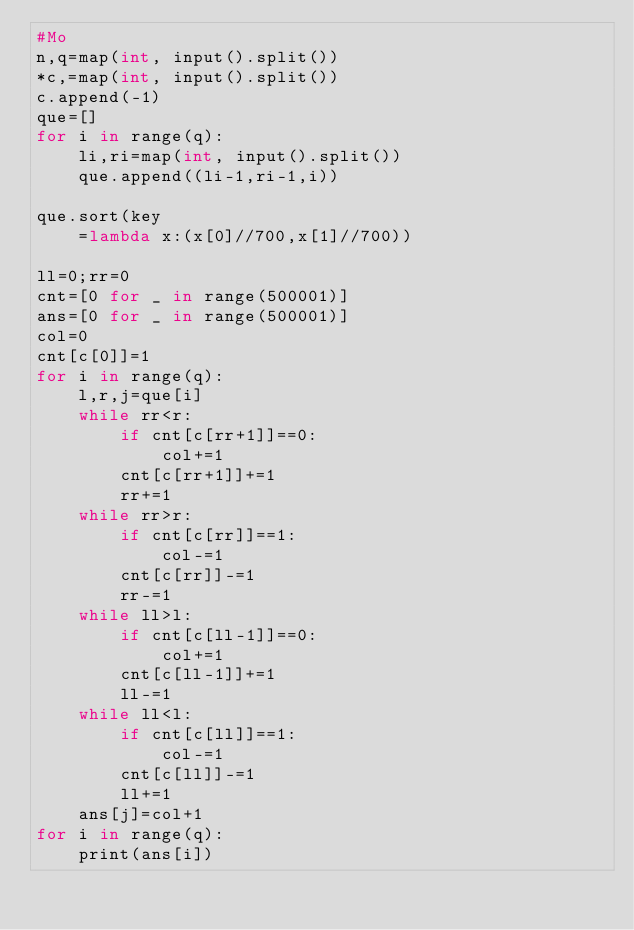Convert code to text. <code><loc_0><loc_0><loc_500><loc_500><_Cython_>#Mo
n,q=map(int, input().split())
*c,=map(int, input().split())
c.append(-1)
que=[]
for i in range(q):
    li,ri=map(int, input().split())
    que.append((li-1,ri-1,i))

que.sort(key
    =lambda x:(x[0]//700,x[1]//700))

ll=0;rr=0
cnt=[0 for _ in range(500001)]
ans=[0 for _ in range(500001)]
col=0
cnt[c[0]]=1
for i in range(q):
    l,r,j=que[i]
    while rr<r:
        if cnt[c[rr+1]]==0:
            col+=1
        cnt[c[rr+1]]+=1
        rr+=1
    while rr>r:
        if cnt[c[rr]]==1:
            col-=1
        cnt[c[rr]]-=1
        rr-=1
    while ll>l:
        if cnt[c[ll-1]]==0:
            col+=1
        cnt[c[ll-1]]+=1
        ll-=1
    while ll<l:
        if cnt[c[ll]]==1:
            col-=1
        cnt[c[ll]]-=1
        ll+=1
    ans[j]=col+1
for i in range(q):
    print(ans[i])</code> 